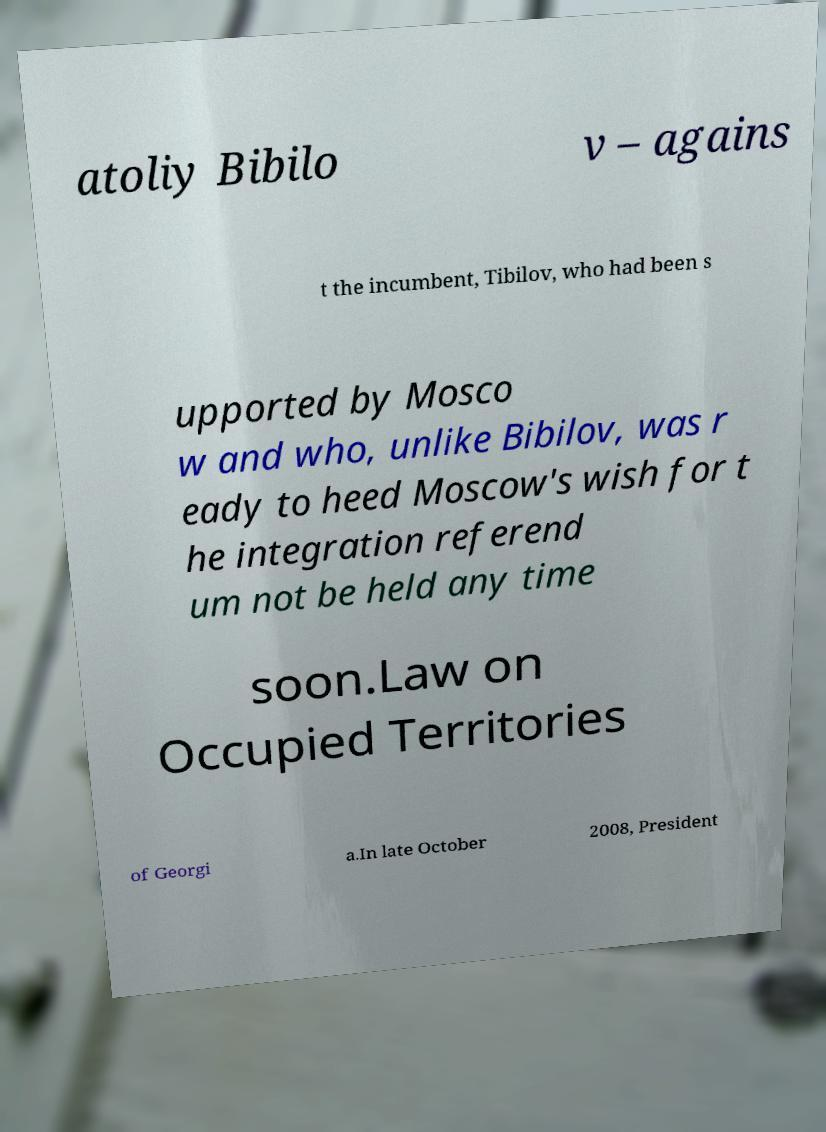What messages or text are displayed in this image? I need them in a readable, typed format. atoliy Bibilo v – agains t the incumbent, Tibilov, who had been s upported by Mosco w and who, unlike Bibilov, was r eady to heed Moscow's wish for t he integration referend um not be held any time soon.Law on Occupied Territories of Georgi a.In late October 2008, President 